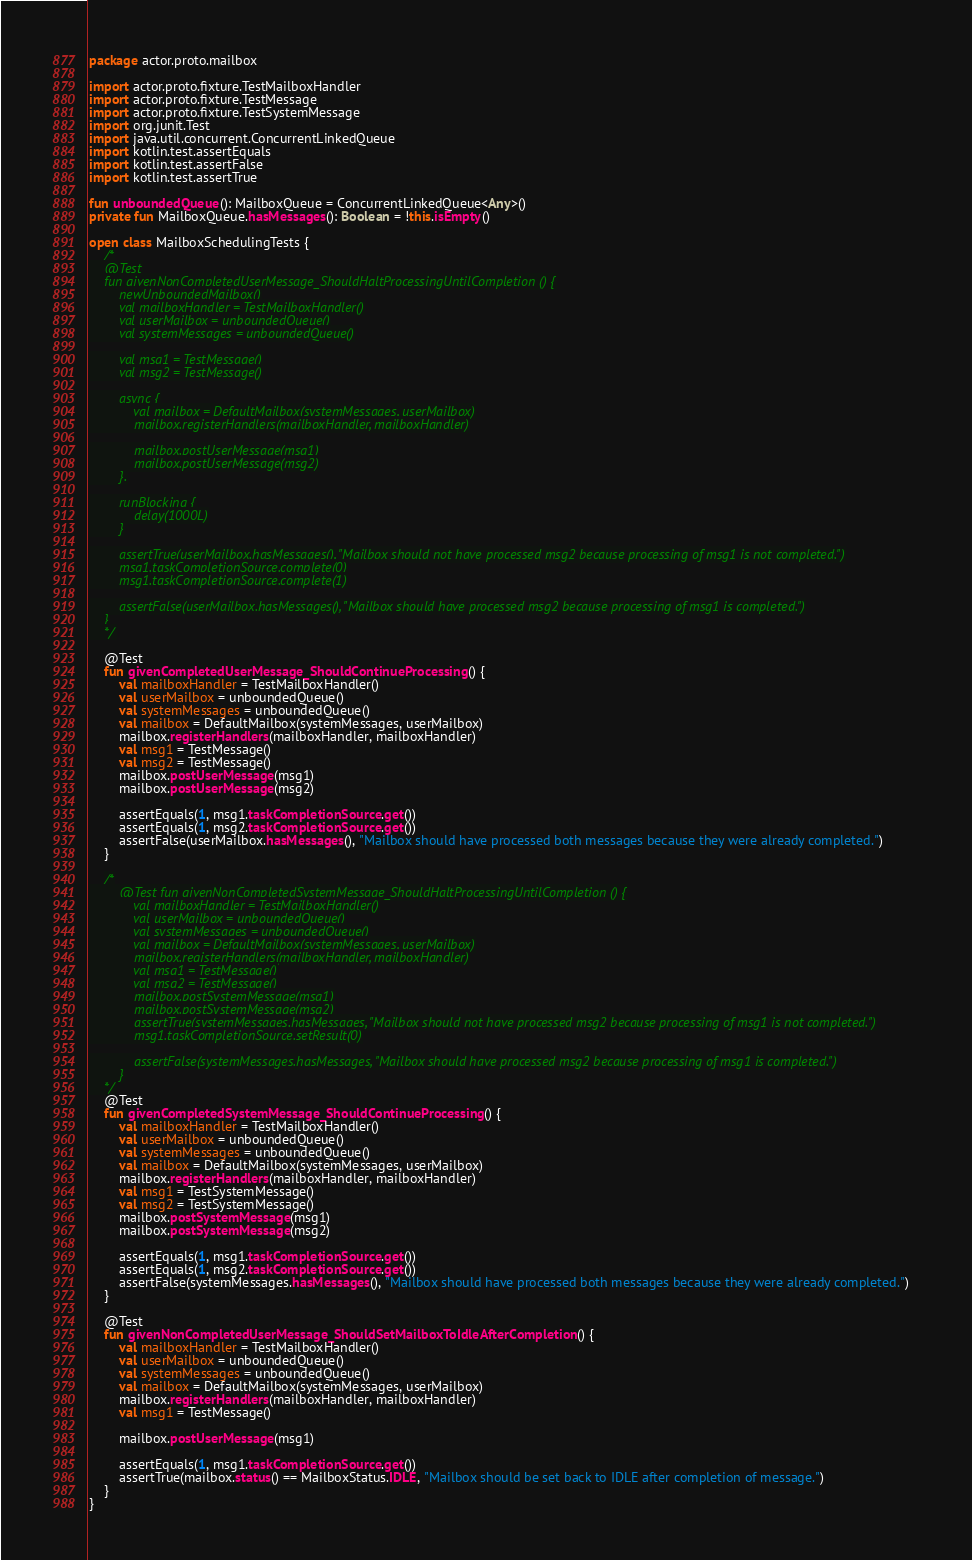<code> <loc_0><loc_0><loc_500><loc_500><_Kotlin_>package actor.proto.mailbox

import actor.proto.fixture.TestMailboxHandler
import actor.proto.fixture.TestMessage
import actor.proto.fixture.TestSystemMessage
import org.junit.Test
import java.util.concurrent.ConcurrentLinkedQueue
import kotlin.test.assertEquals
import kotlin.test.assertFalse
import kotlin.test.assertTrue

fun unboundedQueue(): MailboxQueue = ConcurrentLinkedQueue<Any>()
private fun MailboxQueue.hasMessages(): Boolean = !this.isEmpty()

open class MailboxSchedulingTests {
    /*
    @Test
    fun givenNonCompletedUserMessage_ShouldHaltProcessingUntilCompletion () {
        newUnboundedMailbox()
        val mailboxHandler = TestMailboxHandler()
        val userMailbox = unboundedQueue()
        val systemMessages = unboundedQueue()

        val msg1 = TestMessage()
        val msg2 = TestMessage()

        async {
            val mailbox = DefaultMailbox(systemMessages, userMailbox)
            mailbox.registerHandlers(mailboxHandler, mailboxHandler)

            mailbox.postUserMessage(msg1)
            mailbox.postUserMessage(msg2)
        }.

        runBlocking {
            delay(1000L)
        }

        assertTrue(userMailbox.hasMessages(), "Mailbox should not have processed msg2 because processing of msg1 is not completed.")
        msg1.taskCompletionSource.complete(0)
        msg1.taskCompletionSource.complete(1)

        assertFalse(userMailbox.hasMessages(), "Mailbox should have processed msg2 because processing of msg1 is completed.")
    }
    */

    @Test
    fun givenCompletedUserMessage_ShouldContinueProcessing() {
        val mailboxHandler = TestMailboxHandler()
        val userMailbox = unboundedQueue()
        val systemMessages = unboundedQueue()
        val mailbox = DefaultMailbox(systemMessages, userMailbox)
        mailbox.registerHandlers(mailboxHandler, mailboxHandler)
        val msg1 = TestMessage()
        val msg2 = TestMessage()
        mailbox.postUserMessage(msg1)
        mailbox.postUserMessage(msg2)

        assertEquals(1, msg1.taskCompletionSource.get())
        assertEquals(1, msg2.taskCompletionSource.get())
        assertFalse(userMailbox.hasMessages(), "Mailbox should have processed both messages because they were already completed.")
    }

    /*
        @Test fun givenNonCompletedSystemMessage_ShouldHaltProcessingUntilCompletion () {
            val mailboxHandler = TestMailboxHandler()
            val userMailbox = unboundedQueue()
            val systemMessages = unboundedQueue()
            val mailbox = DefaultMailbox(systemMessages, userMailbox)
            mailbox.registerHandlers(mailboxHandler, mailboxHandler)
            val msg1 = TestMessage()
            val msg2 = TestMessage()
            mailbox.postSystemMessage(msg1)
            mailbox.postSystemMessage(msg2)
            assertTrue(systemMessages.hasMessages, "Mailbox should not have processed msg2 because processing of msg1 is not completed.")
            msg1.taskCompletionSource.setResult(0)

            assertFalse(systemMessages.hasMessages, "Mailbox should have processed msg2 because processing of msg1 is completed.")
        }
    */
    @Test
    fun givenCompletedSystemMessage_ShouldContinueProcessing() {
        val mailboxHandler = TestMailboxHandler()
        val userMailbox = unboundedQueue()
        val systemMessages = unboundedQueue()
        val mailbox = DefaultMailbox(systemMessages, userMailbox)
        mailbox.registerHandlers(mailboxHandler, mailboxHandler)
        val msg1 = TestSystemMessage()
        val msg2 = TestSystemMessage()
        mailbox.postSystemMessage(msg1)
        mailbox.postSystemMessage(msg2)

        assertEquals(1, msg1.taskCompletionSource.get())
        assertEquals(1, msg2.taskCompletionSource.get())
        assertFalse(systemMessages.hasMessages(), "Mailbox should have processed both messages because they were already completed.")
    }

    @Test
    fun givenNonCompletedUserMessage_ShouldSetMailboxToIdleAfterCompletion() {
        val mailboxHandler = TestMailboxHandler()
        val userMailbox = unboundedQueue()
        val systemMessages = unboundedQueue()
        val mailbox = DefaultMailbox(systemMessages, userMailbox)
        mailbox.registerHandlers(mailboxHandler, mailboxHandler)
        val msg1 = TestMessage()

        mailbox.postUserMessage(msg1)

        assertEquals(1, msg1.taskCompletionSource.get())
        assertTrue(mailbox.status() == MailboxStatus.IDLE, "Mailbox should be set back to IDLE after completion of message.")
    }
}
</code> 